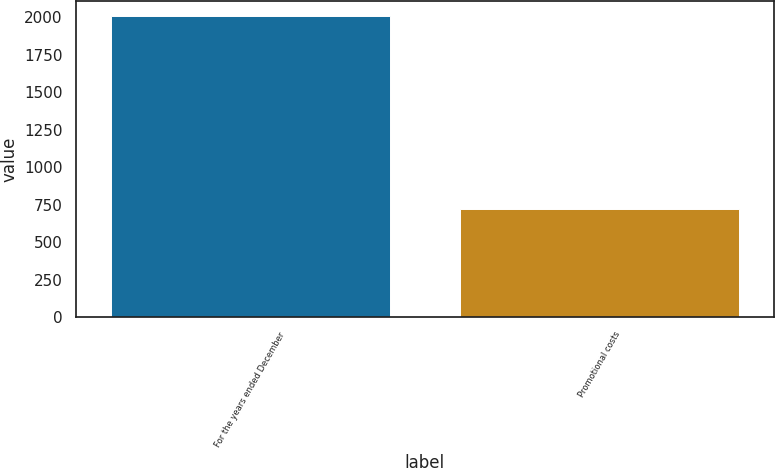<chart> <loc_0><loc_0><loc_500><loc_500><bar_chart><fcel>For the years ended December<fcel>Promotional costs<nl><fcel>2009<fcel>721.5<nl></chart> 